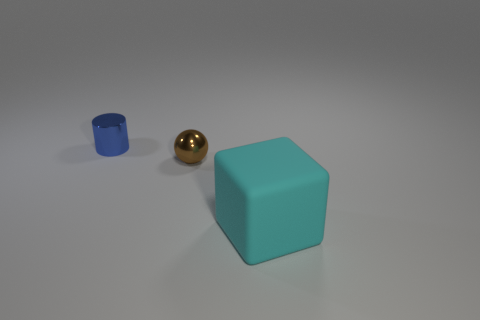There is a metallic object that is on the left side of the brown shiny object; what shape is it?
Provide a succinct answer. Cylinder. Is the number of cyan objects that are behind the big thing less than the number of large cyan rubber things behind the tiny brown object?
Provide a succinct answer. No. There is a brown thing; is its size the same as the cyan matte block that is right of the blue metal thing?
Make the answer very short. No. What number of brown spheres have the same size as the blue metallic object?
Ensure brevity in your answer.  1. There is a cylinder that is made of the same material as the tiny sphere; what color is it?
Ensure brevity in your answer.  Blue. Is the number of large yellow metallic spheres greater than the number of tiny spheres?
Your response must be concise. No. Are the blue object and the sphere made of the same material?
Your answer should be compact. Yes. There is another tiny object that is the same material as the brown thing; what shape is it?
Give a very brief answer. Cylinder. Is the number of brown things less than the number of tiny metallic cubes?
Make the answer very short. No. What is the material of the object that is both in front of the tiny blue metallic thing and to the left of the cyan cube?
Give a very brief answer. Metal. 